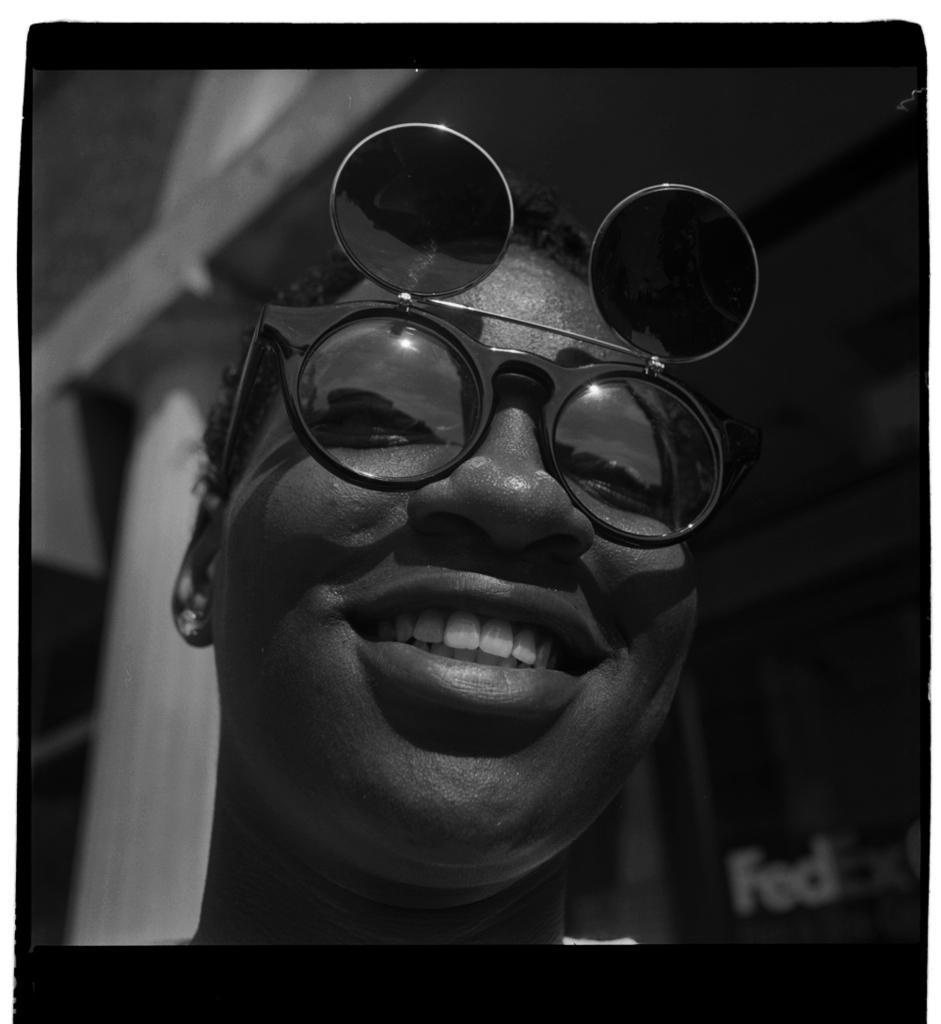Could you give a brief overview of what you see in this image? I see this is a black and white image and I see a person's face over here and I see shades and I see that the person is smiling and it is blurred in the background and I see alphabets over here. 